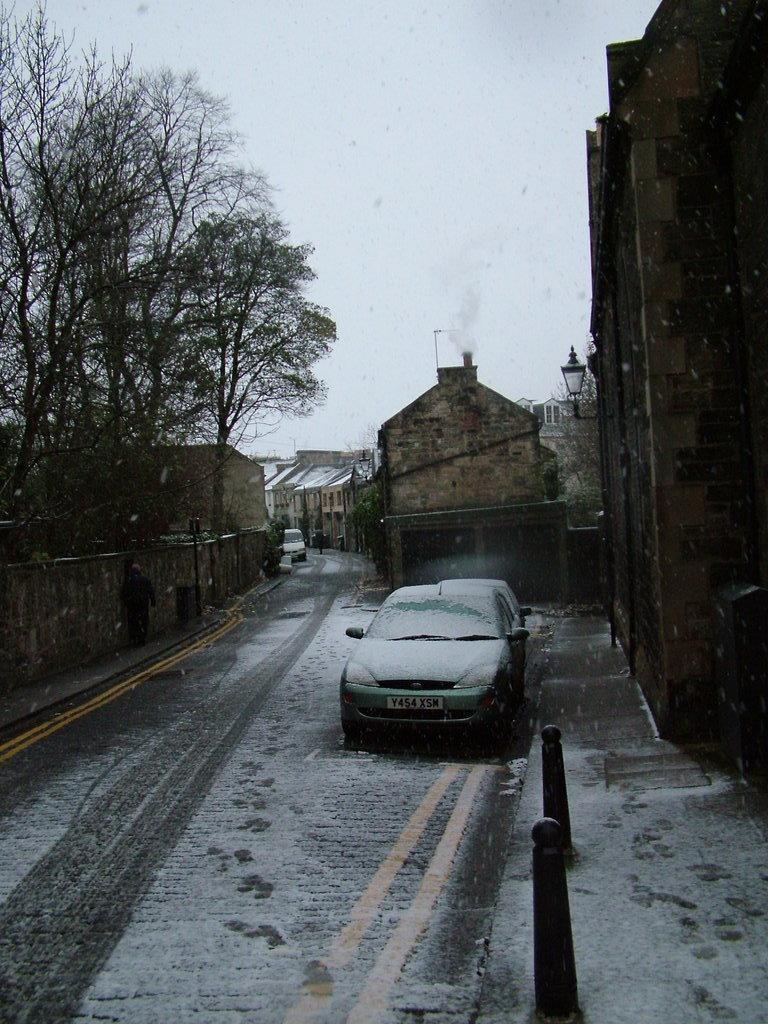What is the main feature of the image? There is a road in the image. What is a notable characteristic of the road? The road has snow on it. What else can be seen on the road? There are cars on the road. What else is visible in the image besides the road and cars? There are buildings, trees, and poles visible in the image. What is visible in the background of the image? The sky is visible in the background of the image. What type of verse can be heard being recited on the stage in the image? There is no stage or verse present in the image; it features a snowy road with cars, buildings, trees, and poles. What tool is being used to fix the wrench in the image? There is no wrench present in the image; it features a snowy road with cars, buildings, trees, and poles. 